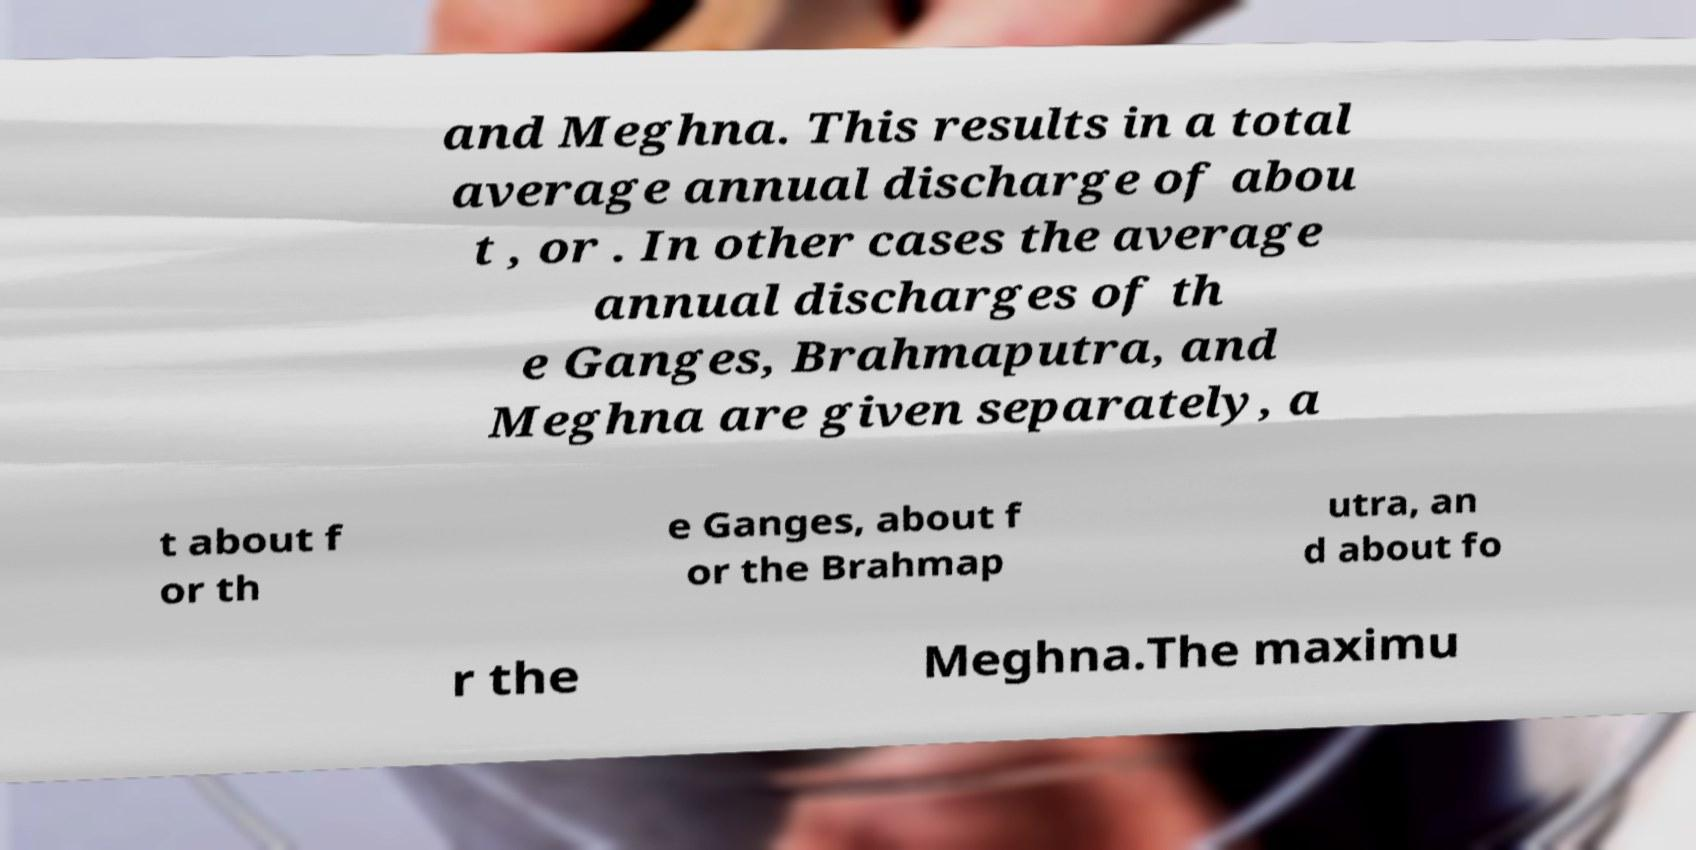Please identify and transcribe the text found in this image. and Meghna. This results in a total average annual discharge of abou t , or . In other cases the average annual discharges of th e Ganges, Brahmaputra, and Meghna are given separately, a t about f or th e Ganges, about f or the Brahmap utra, an d about fo r the Meghna.The maximu 